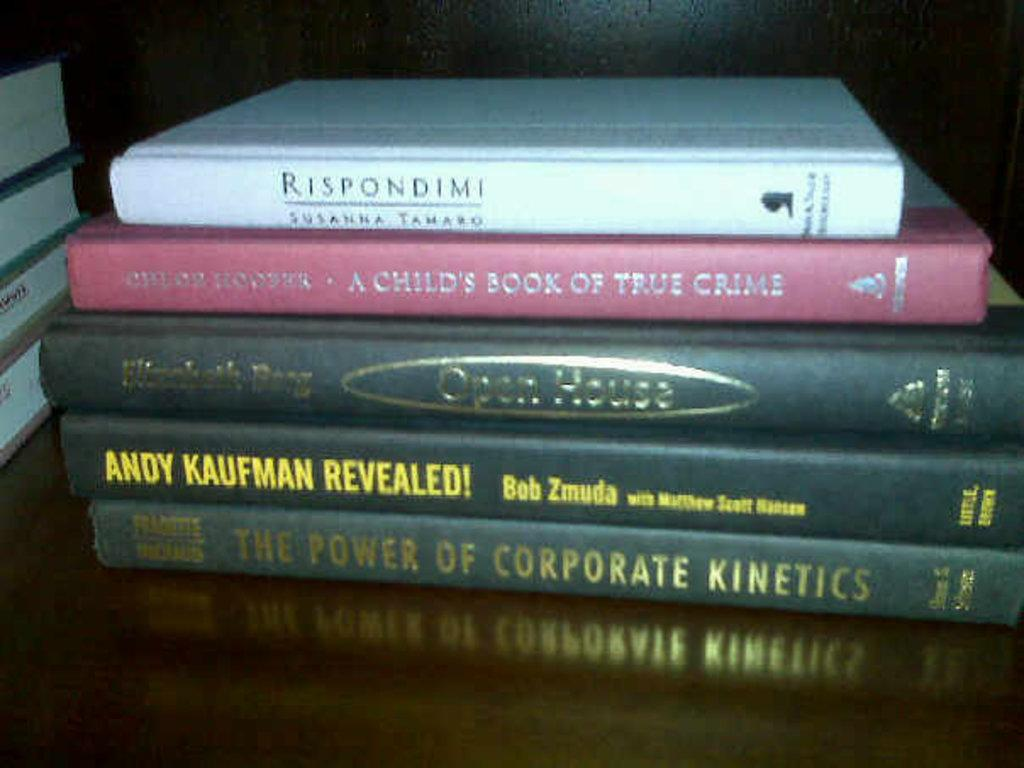<image>
Provide a brief description of the given image. Book titled "The Power of Corporate Kinetics" on the bottome of a stack of books. 